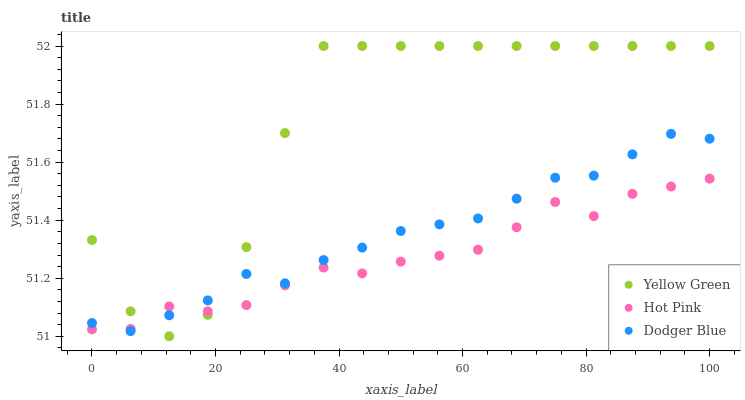Does Hot Pink have the minimum area under the curve?
Answer yes or no. Yes. Does Yellow Green have the maximum area under the curve?
Answer yes or no. Yes. Does Dodger Blue have the minimum area under the curve?
Answer yes or no. No. Does Dodger Blue have the maximum area under the curve?
Answer yes or no. No. Is Dodger Blue the smoothest?
Answer yes or no. Yes. Is Yellow Green the roughest?
Answer yes or no. Yes. Is Yellow Green the smoothest?
Answer yes or no. No. Is Dodger Blue the roughest?
Answer yes or no. No. Does Yellow Green have the lowest value?
Answer yes or no. Yes. Does Dodger Blue have the lowest value?
Answer yes or no. No. Does Yellow Green have the highest value?
Answer yes or no. Yes. Does Dodger Blue have the highest value?
Answer yes or no. No. Does Hot Pink intersect Dodger Blue?
Answer yes or no. Yes. Is Hot Pink less than Dodger Blue?
Answer yes or no. No. Is Hot Pink greater than Dodger Blue?
Answer yes or no. No. 